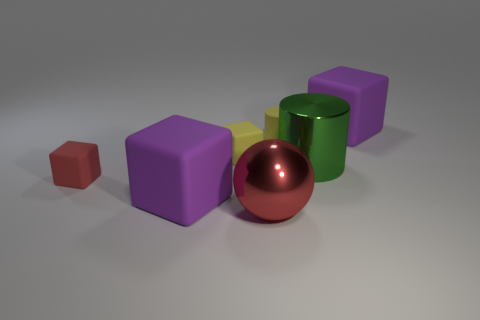Add 1 red metallic objects. How many objects exist? 8 Subtract all cylinders. How many objects are left? 5 Add 1 big metal balls. How many big metal balls exist? 2 Subtract 0 red cylinders. How many objects are left? 7 Subtract all purple things. Subtract all yellow cylinders. How many objects are left? 4 Add 5 yellow matte things. How many yellow matte things are left? 7 